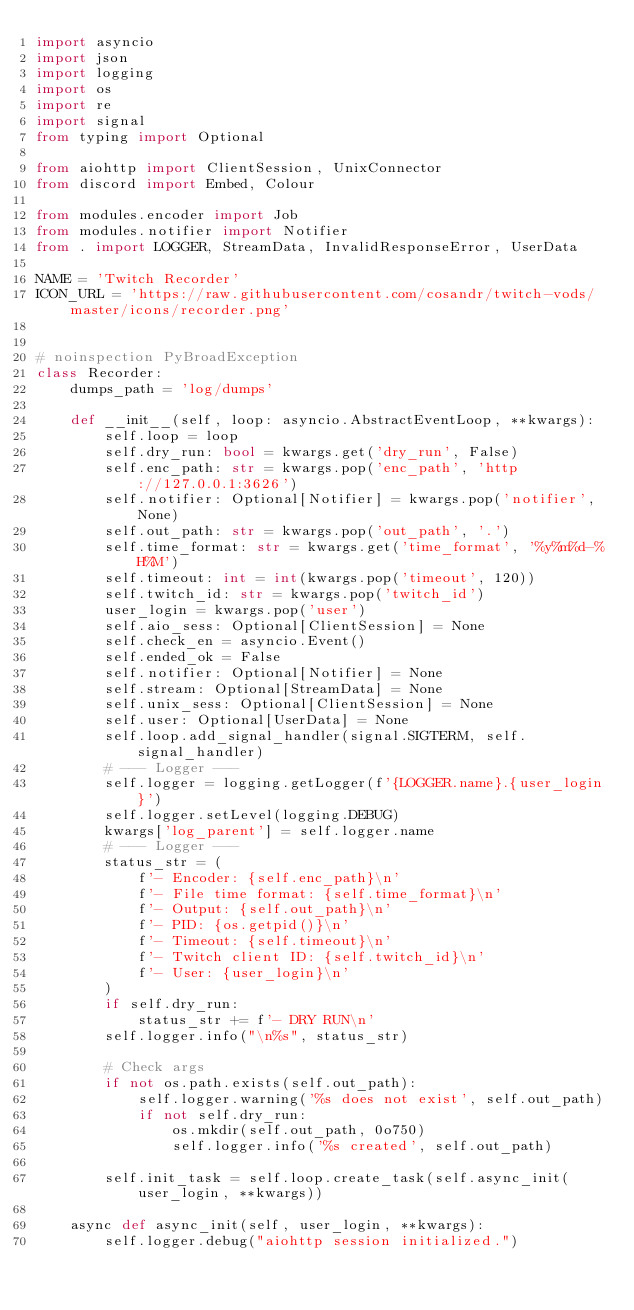Convert code to text. <code><loc_0><loc_0><loc_500><loc_500><_Python_>import asyncio
import json
import logging
import os
import re
import signal
from typing import Optional

from aiohttp import ClientSession, UnixConnector
from discord import Embed, Colour

from modules.encoder import Job
from modules.notifier import Notifier
from . import LOGGER, StreamData, InvalidResponseError, UserData

NAME = 'Twitch Recorder'
ICON_URL = 'https://raw.githubusercontent.com/cosandr/twitch-vods/master/icons/recorder.png'


# noinspection PyBroadException
class Recorder:
    dumps_path = 'log/dumps'

    def __init__(self, loop: asyncio.AbstractEventLoop, **kwargs):
        self.loop = loop
        self.dry_run: bool = kwargs.get('dry_run', False)
        self.enc_path: str = kwargs.pop('enc_path', 'http://127.0.0.1:3626')
        self.notifier: Optional[Notifier] = kwargs.pop('notifier', None)
        self.out_path: str = kwargs.pop('out_path', '.')
        self.time_format: str = kwargs.get('time_format', '%y%m%d-%H%M')
        self.timeout: int = int(kwargs.pop('timeout', 120))
        self.twitch_id: str = kwargs.pop('twitch_id')
        user_login = kwargs.pop('user')
        self.aio_sess: Optional[ClientSession] = None
        self.check_en = asyncio.Event()
        self.ended_ok = False
        self.notifier: Optional[Notifier] = None
        self.stream: Optional[StreamData] = None
        self.unix_sess: Optional[ClientSession] = None
        self.user: Optional[UserData] = None
        self.loop.add_signal_handler(signal.SIGTERM, self.signal_handler)
        # --- Logger ---
        self.logger = logging.getLogger(f'{LOGGER.name}.{user_login}')
        self.logger.setLevel(logging.DEBUG)
        kwargs['log_parent'] = self.logger.name
        # --- Logger ---
        status_str = (
            f'- Encoder: {self.enc_path}\n'
            f'- File time format: {self.time_format}\n'
            f'- Output: {self.out_path}\n'
            f'- PID: {os.getpid()}\n'
            f'- Timeout: {self.timeout}\n'
            f'- Twitch client ID: {self.twitch_id}\n'
            f'- User: {user_login}\n'
        )
        if self.dry_run:
            status_str += f'- DRY RUN\n'
        self.logger.info("\n%s", status_str)

        # Check args
        if not os.path.exists(self.out_path):
            self.logger.warning('%s does not exist', self.out_path)
            if not self.dry_run:
                os.mkdir(self.out_path, 0o750)
                self.logger.info('%s created', self.out_path)

        self.init_task = self.loop.create_task(self.async_init(user_login, **kwargs))

    async def async_init(self, user_login, **kwargs):
        self.logger.debug("aiohttp session initialized.")</code> 